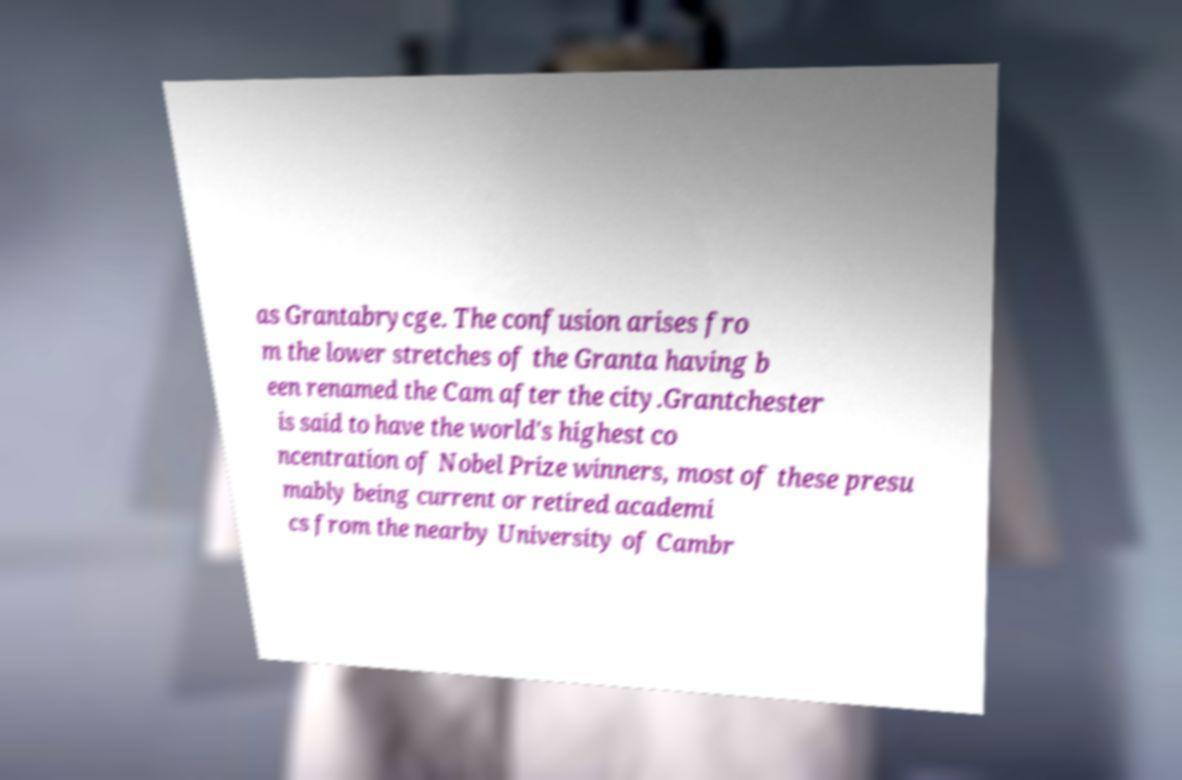For documentation purposes, I need the text within this image transcribed. Could you provide that? as Grantabrycge. The confusion arises fro m the lower stretches of the Granta having b een renamed the Cam after the city.Grantchester is said to have the world's highest co ncentration of Nobel Prize winners, most of these presu mably being current or retired academi cs from the nearby University of Cambr 